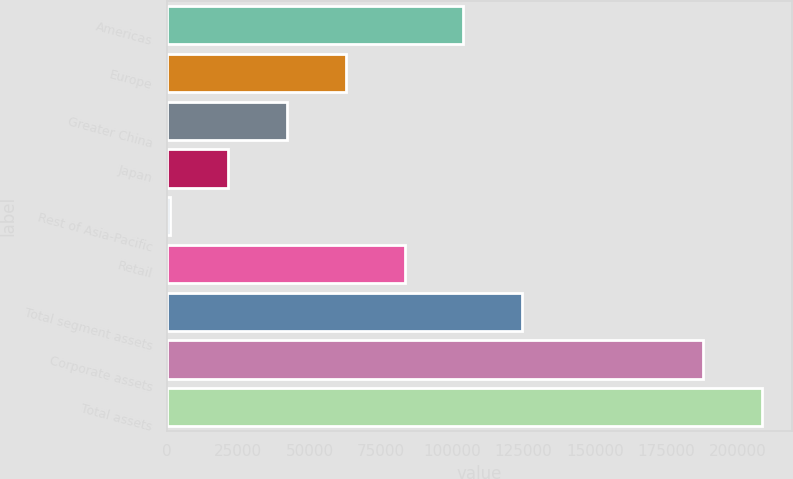Convert chart to OTSL. <chart><loc_0><loc_0><loc_500><loc_500><bar_chart><fcel>Americas<fcel>Europe<fcel>Greater China<fcel>Japan<fcel>Rest of Asia-Pacific<fcel>Retail<fcel>Total segment assets<fcel>Corporate assets<fcel>Total assets<nl><fcel>103962<fcel>62746.1<fcel>42138.4<fcel>21530.7<fcel>923<fcel>83353.8<fcel>124569<fcel>188086<fcel>208694<nl></chart> 